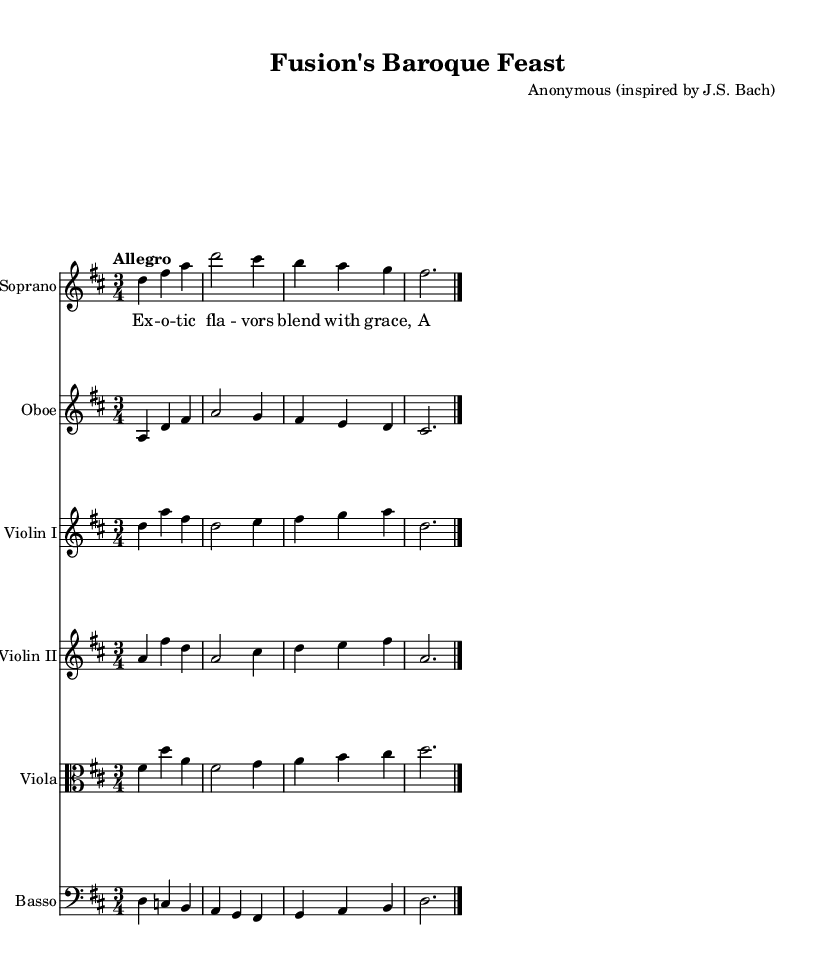What is the key signature of this music? The key signature indicates two sharps, which corresponds to the key of D major.
Answer: D major What is the time signature of this music? The time signature is indicated at the beginning and shows 3/4, meaning there are three beats in each measure.
Answer: 3/4 What does the tempo marking indicate? The tempo marking is "Allegro," which suggests a fast and lively pace for the piece, typically around 120-168 beats per minute.
Answer: Allegro How many instrumental parts are present in this score? The score lists a total of six distinct staff parts, which includes soprano, oboe, two violins, viola, and basso.
Answer: Six What type of musical form is used in this piece? The piece has a typical Baroque structure characterized by alternating sections of melody and accompaniment, often involving counterpoint and harmonization.
Answer: Cantata Which instrument plays the melody in the first measure? The soprano part carries the melody at the beginning of the piece, starting with the note D, while the other instruments provide accompaniment.
Answer: Soprano What is the lyrical theme conveyed in the verse? The lyrics describe the blending of exotic flavors with grace, highlighting a culinary theme that celebrates innovation and fusion cuisine.
Answer: Culinary innovation 